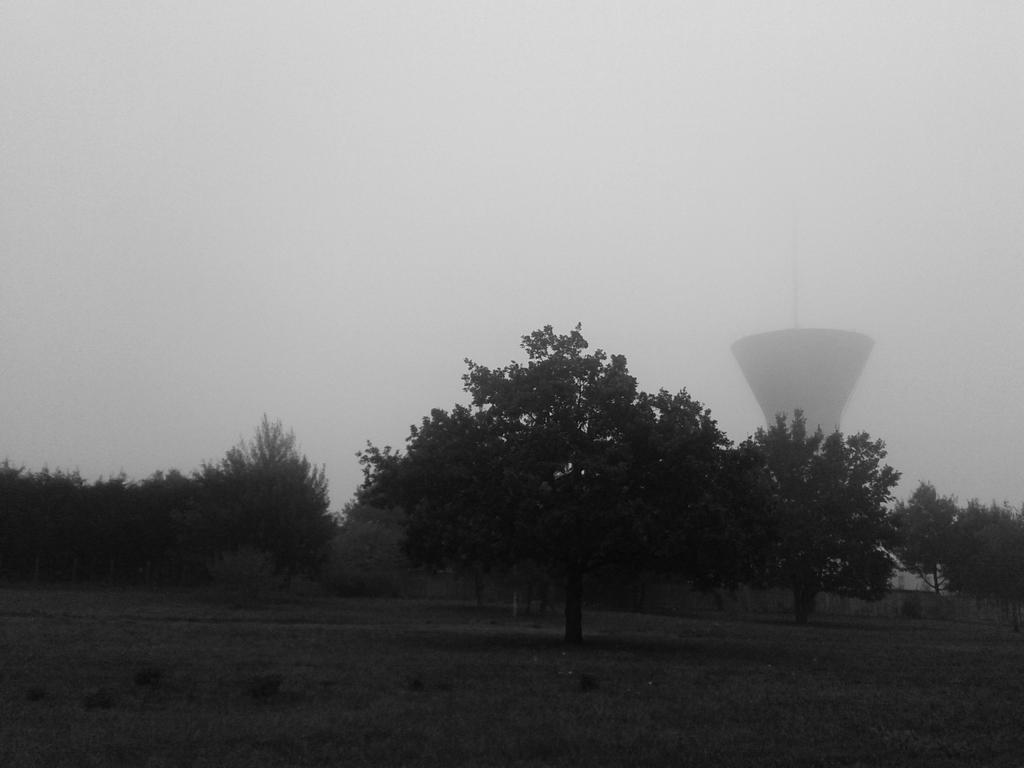What is the color scheme of the image? The image is black and white. What type of vegetation can be seen in the image? There are trees in the image. What structure is present in the image? There is a tower in the image. What is visible at the top of the image? The sky is visible in the image. What is the mind of the grandmother in the image? There is no reference to a mind or a grandmother in the image, as it only features trees, a tower, and the sky. What is the condition of the grandmother in the image? There is no grandmother present in the image, so it is not possible to determine her condition. 